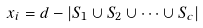<formula> <loc_0><loc_0><loc_500><loc_500>x _ { i } = d - | S _ { 1 } \cup S _ { 2 } \cup \cdots \cup S _ { c } |</formula> 